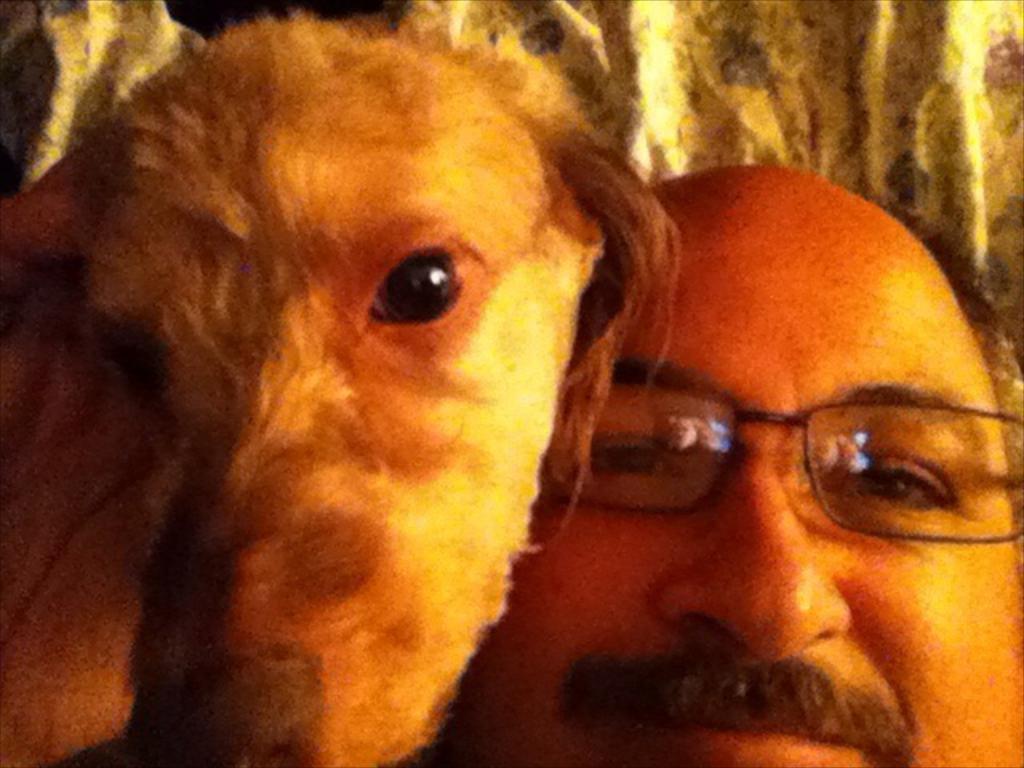In one or two sentences, can you explain what this image depicts? In this picture there is a man smiling and wearing a spectacles. Beside him there is a dog. In the background there is a pillow. 